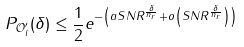<formula> <loc_0><loc_0><loc_500><loc_500>P _ { \mathcal { O } _ { l } ^ { \prime } } ( \delta ) \leq \frac { 1 } { 2 } e ^ { - \left ( a S N R ^ { \frac { \delta } { n _ { r } } } + o \left ( S N R ^ { \frac { \delta } { n _ { r } } } \right ) \right ) }</formula> 